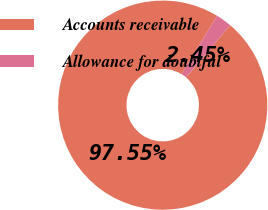Convert chart. <chart><loc_0><loc_0><loc_500><loc_500><pie_chart><fcel>Accounts receivable<fcel>Allowance for doubtful<nl><fcel>97.55%<fcel>2.45%<nl></chart> 